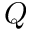<formula> <loc_0><loc_0><loc_500><loc_500>Q</formula> 